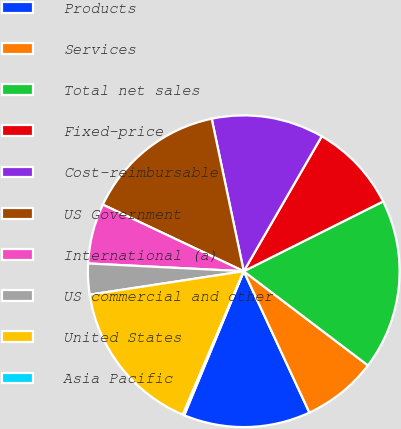Convert chart. <chart><loc_0><loc_0><loc_500><loc_500><pie_chart><fcel>Products<fcel>Services<fcel>Total net sales<fcel>Fixed-price<fcel>Cost-reimbursable<fcel>US Government<fcel>International (a)<fcel>US commercial and other<fcel>United States<fcel>Asia Pacific<nl><fcel>13.16%<fcel>7.75%<fcel>17.72%<fcel>9.27%<fcel>11.64%<fcel>14.68%<fcel>6.23%<fcel>3.2%<fcel>16.2%<fcel>0.16%<nl></chart> 